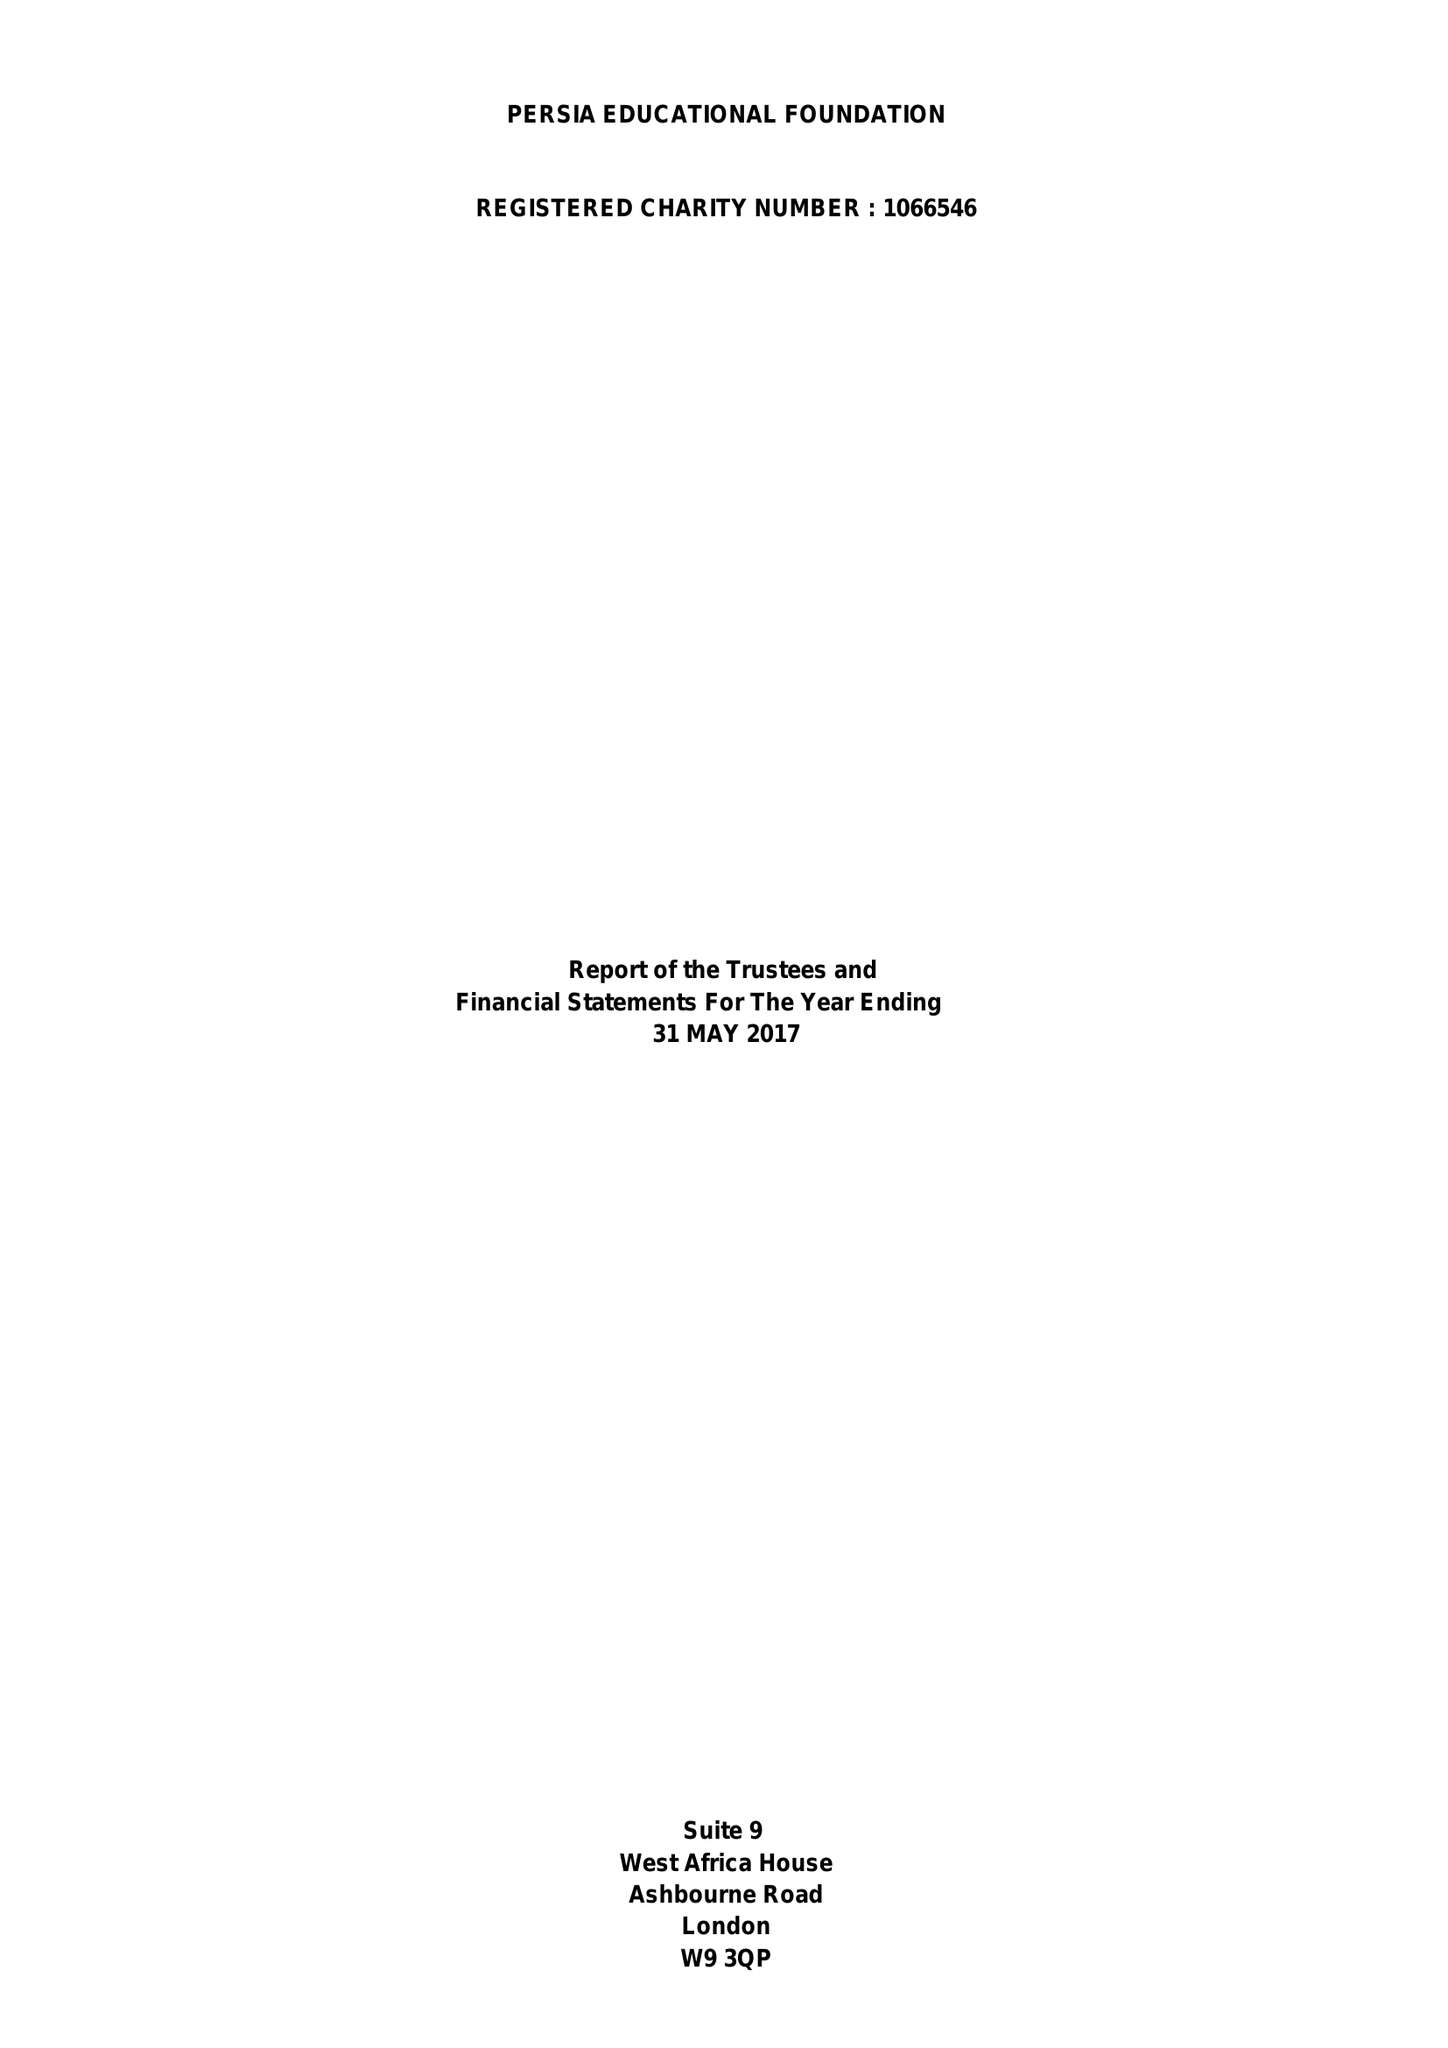What is the value for the address__street_line?
Answer the question using a single word or phrase. ASHBOURNE ROAD 